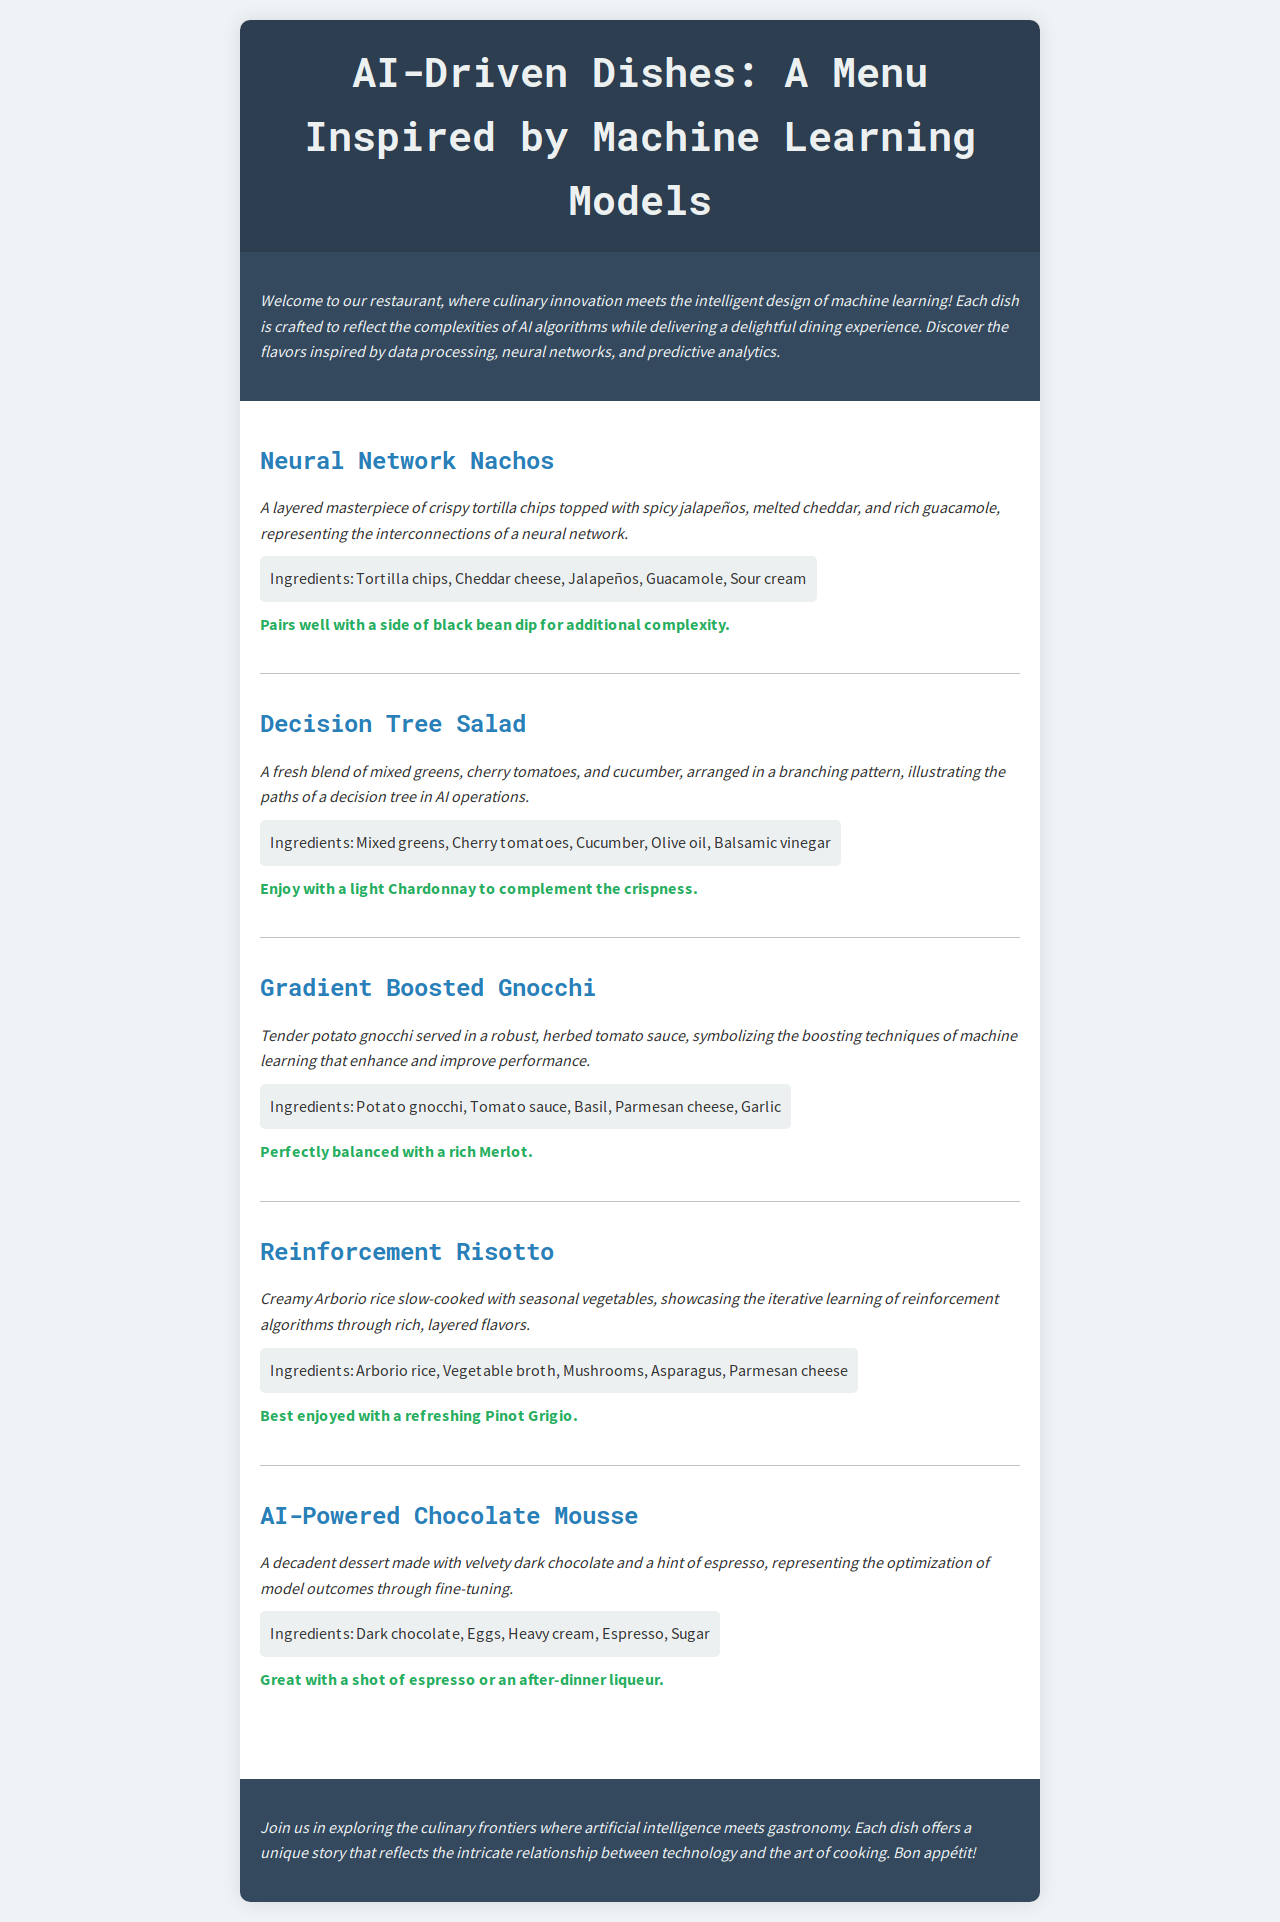What is the first dish on the menu? The first dish listed in the menu is called "Neural Network Nachos."
Answer: Neural Network Nachos What type of cheese is used in the Neural Network Nachos? The cheese used in the Neural Network Nachos is Cheddar cheese.
Answer: Cheddar cheese How many dishes are listed in the menu? There are five dishes included in the menu.
Answer: Five What ingredient is featured in the Decision Tree Salad? A featured ingredient in the Decision Tree Salad is Cherry tomatoes.
Answer: Cherry tomatoes What beverage pairs well with the Gradient Boosted Gnocchi? The beverage that pairs well with Gradient Boosted Gnocchi is Merlot.
Answer: Merlot Which dish represents the iterative learning of reinforcement algorithms? The dish that showcases the iterative learning of reinforcement algorithms is Reinforcement Risotto.
Answer: Reinforcement Risotto What is the main ingredient in AI-Powered Chocolate Mousse? The main ingredient in AI-Powered Chocolate Mousse is Dark chocolate.
Answer: Dark chocolate What is the cooking style of the Reinforcement Risotto? The cooking style of the Reinforcement Risotto is slow-cooked.
Answer: Slow-cooked What is the color scheme of the menu background? The color scheme of the menu background is light gray (#f0f3f5).
Answer: Light gray 